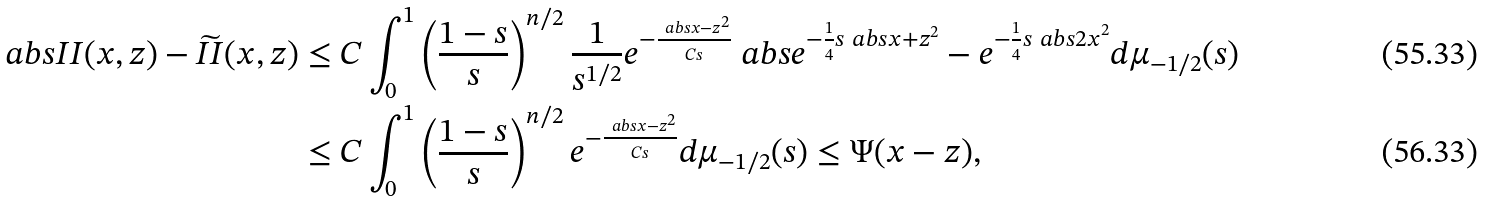Convert formula to latex. <formula><loc_0><loc_0><loc_500><loc_500>\ a b s { I I ( x , z ) - \widetilde { I I } ( x , z ) } & \leq C \int _ { 0 } ^ { 1 } \left ( \frac { 1 - s } { s } \right ) ^ { n / 2 } \frac { 1 } { s ^ { 1 / 2 } } e ^ { - \frac { \ a b s { x - z } ^ { 2 } } { C s } } \ a b s { e ^ { - \frac { 1 } { 4 } s \ a b s { x + z } ^ { 2 } } - e ^ { - \frac { 1 } { 4 } s \ a b s { 2 x } ^ { 2 } } } d \mu _ { - 1 / 2 } ( s ) \\ & \leq C \int _ { 0 } ^ { 1 } \left ( \frac { 1 - s } { s } \right ) ^ { n / 2 } e ^ { - \frac { \ a b s { x - z } ^ { 2 } } { C s } } d \mu _ { - 1 / 2 } ( s ) \leq \Psi ( x - z ) ,</formula> 